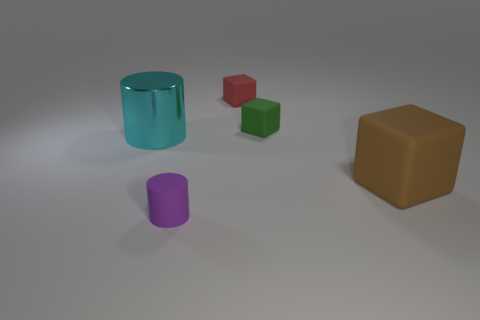Do the cylinder in front of the big cyan thing and the big cyan thing have the same material? No, they do not. The cylinder in front appears to have a matte finish, indicative of a more diffuse reflection of the light, while the larger cyan object has a glossier surface, reflecting light in a more concentrated manner, suggesting that it is made of a different material. 